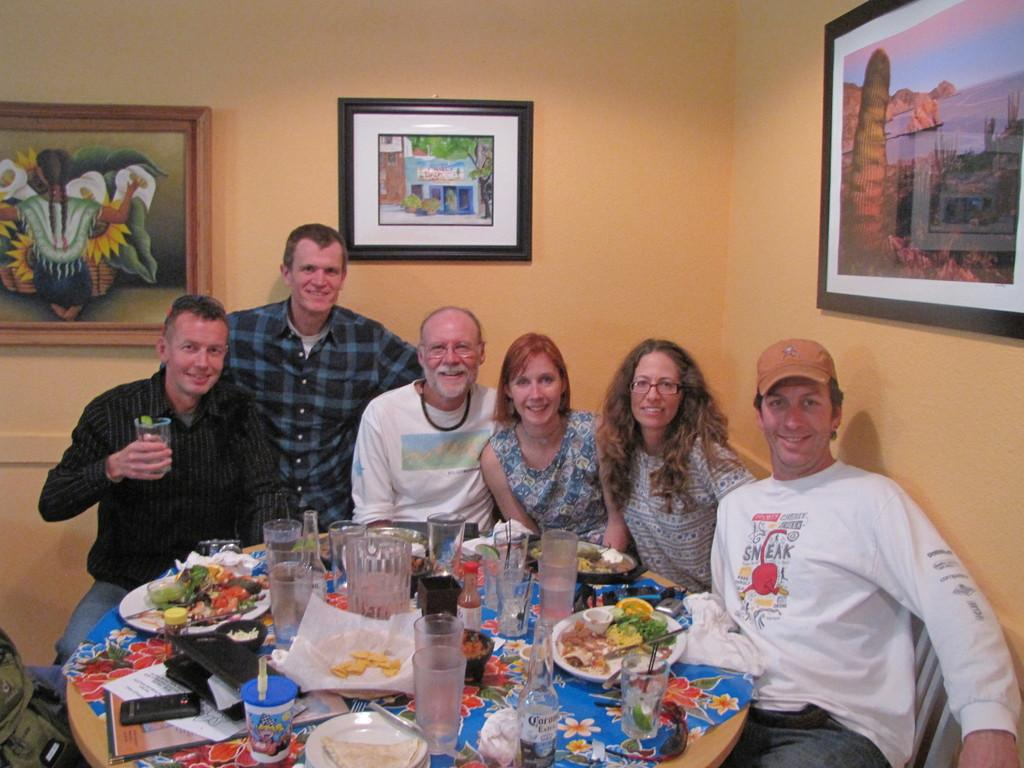How many people are in the image? There are several people in the image. What are the people doing in the image? The people are sitting on chairs. What can be seen on the table in the image? There are bottled and plates in the image. What type of food is present in the image? There is food in the image. What can be seen on the walls in the image? There are photographs and a painting on the wall in the image. Can you see a kitty playing with a foot in the image? There is no kitty or foot present in the image. 